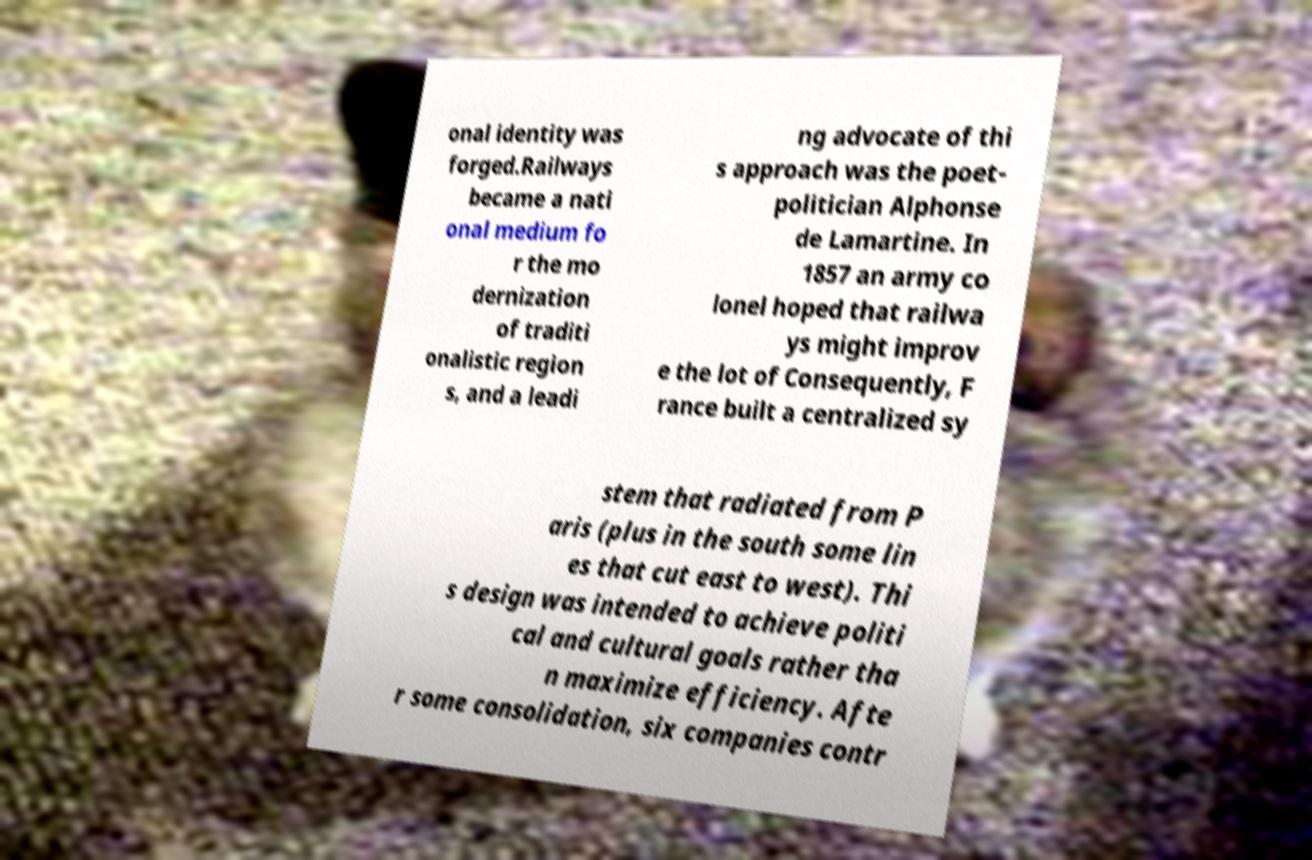Can you read and provide the text displayed in the image?This photo seems to have some interesting text. Can you extract and type it out for me? onal identity was forged.Railways became a nati onal medium fo r the mo dernization of traditi onalistic region s, and a leadi ng advocate of thi s approach was the poet- politician Alphonse de Lamartine. In 1857 an army co lonel hoped that railwa ys might improv e the lot of Consequently, F rance built a centralized sy stem that radiated from P aris (plus in the south some lin es that cut east to west). Thi s design was intended to achieve politi cal and cultural goals rather tha n maximize efficiency. Afte r some consolidation, six companies contr 